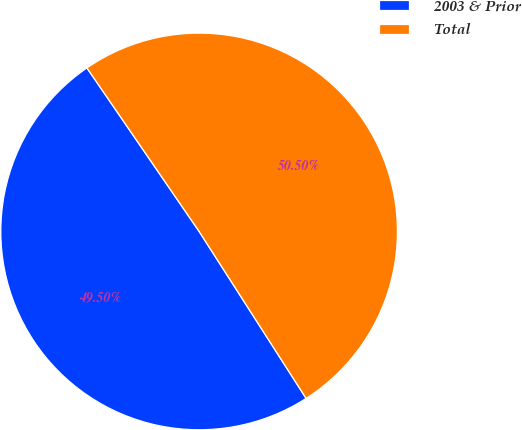Convert chart. <chart><loc_0><loc_0><loc_500><loc_500><pie_chart><fcel>2003 & Prior<fcel>Total<nl><fcel>49.5%<fcel>50.5%<nl></chart> 